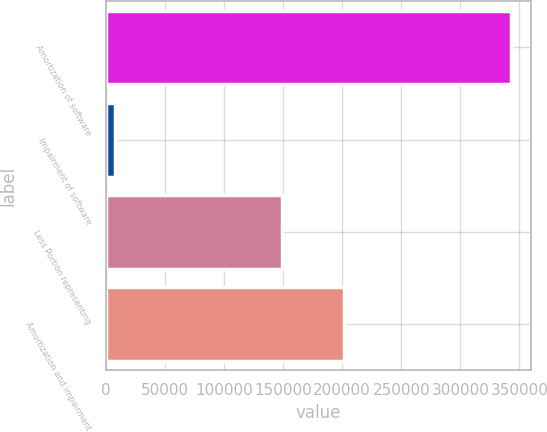Convert chart to OTSL. <chart><loc_0><loc_0><loc_500><loc_500><bar_chart><fcel>Amortization of software<fcel>Impairment of software<fcel>Less Portion representing<fcel>Amortization and impairment<nl><fcel>342870<fcel>7426<fcel>149075<fcel>201221<nl></chart> 